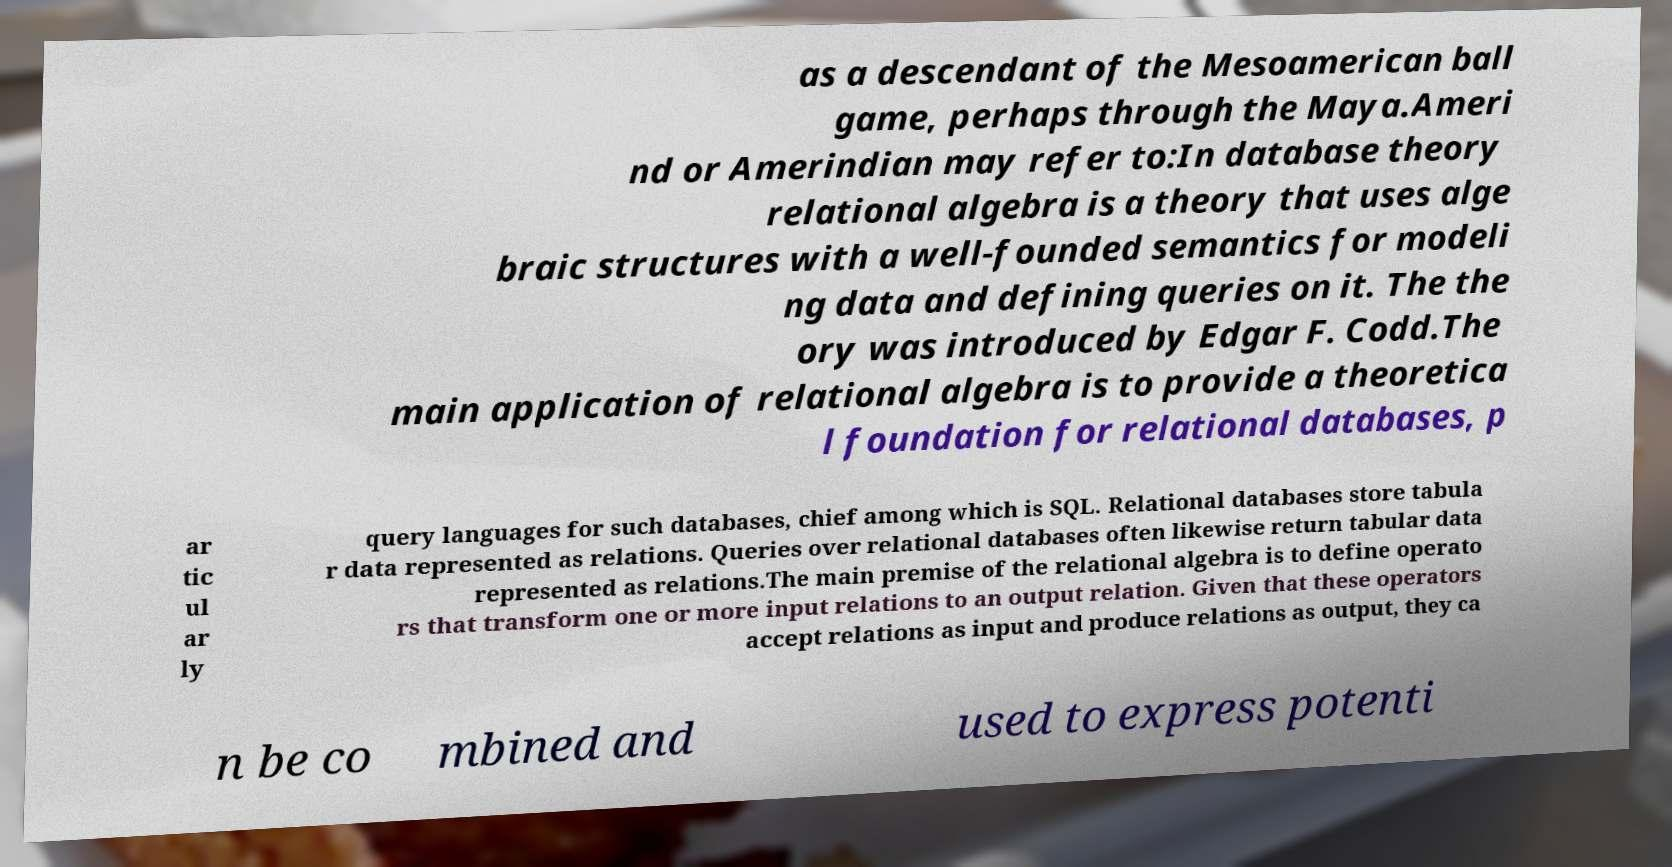What messages or text are displayed in this image? I need them in a readable, typed format. as a descendant of the Mesoamerican ball game, perhaps through the Maya.Ameri nd or Amerindian may refer to:In database theory relational algebra is a theory that uses alge braic structures with a well-founded semantics for modeli ng data and defining queries on it. The the ory was introduced by Edgar F. Codd.The main application of relational algebra is to provide a theoretica l foundation for relational databases, p ar tic ul ar ly query languages for such databases, chief among which is SQL. Relational databases store tabula r data represented as relations. Queries over relational databases often likewise return tabular data represented as relations.The main premise of the relational algebra is to define operato rs that transform one or more input relations to an output relation. Given that these operators accept relations as input and produce relations as output, they ca n be co mbined and used to express potenti 